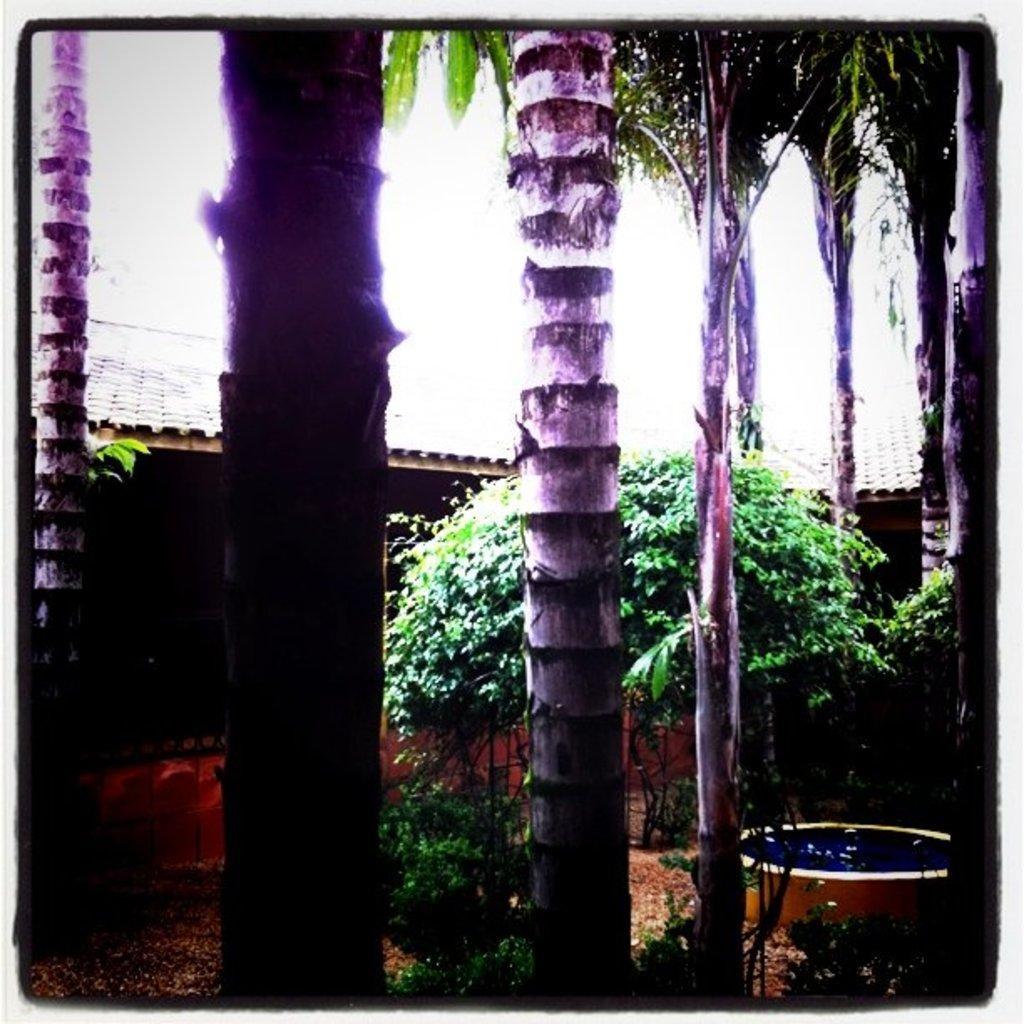Can you describe this image briefly? In this image, we can see trees, plants, small pool and sheds. 